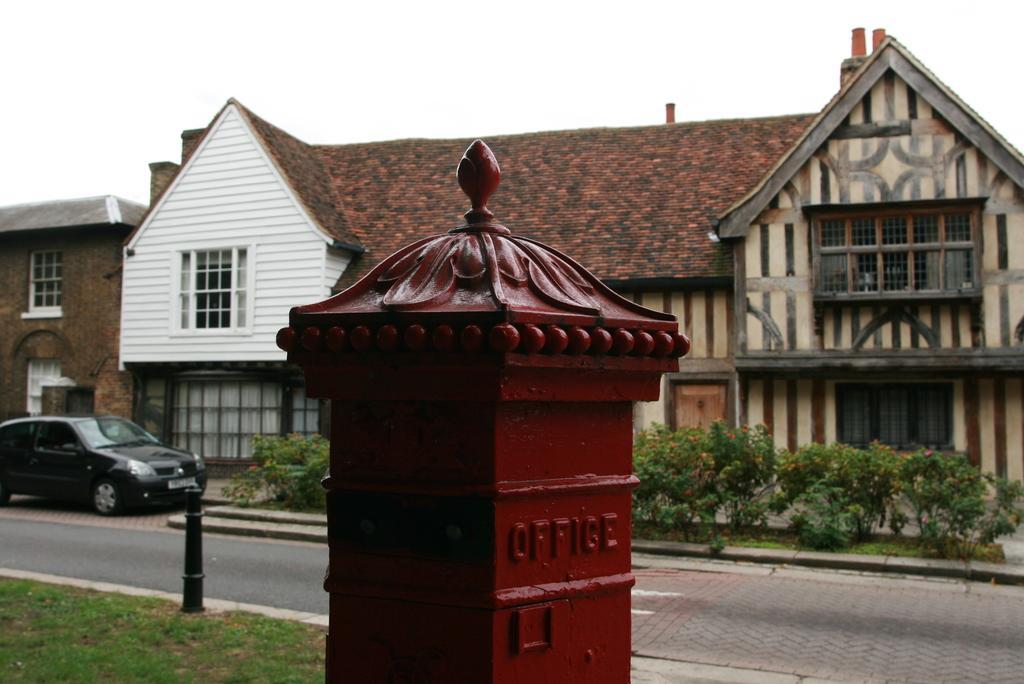In one or two sentences, can you explain what this image depicts? In the image we can see the house and the windows. Here we can see the vehicle and the road. Here we can see poles, grass, plants and the sky.  